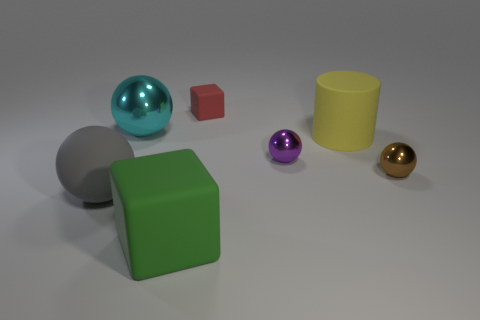How many other things are the same shape as the big yellow thing?
Offer a very short reply. 0. What is the shape of the thing that is both in front of the big matte cylinder and right of the tiny purple thing?
Keep it short and to the point. Sphere. Is the yellow thing the same size as the purple object?
Ensure brevity in your answer.  No. There is a thing that is behind the tiny brown sphere and on the right side of the purple shiny ball; what is its size?
Provide a short and direct response. Large. The matte cylinder has what color?
Your answer should be very brief. Yellow. Are there any other objects of the same shape as the red matte thing?
Offer a terse response. Yes. What shape is the gray object that is the same size as the cyan sphere?
Provide a succinct answer. Sphere. There is a large rubber object that is right of the small object that is behind the cyan shiny ball to the left of the big yellow rubber object; what shape is it?
Keep it short and to the point. Cylinder. Is the shape of the tiny brown thing the same as the tiny thing behind the cylinder?
Offer a very short reply. No. How many small things are matte spheres or brown rubber spheres?
Provide a short and direct response. 0. 